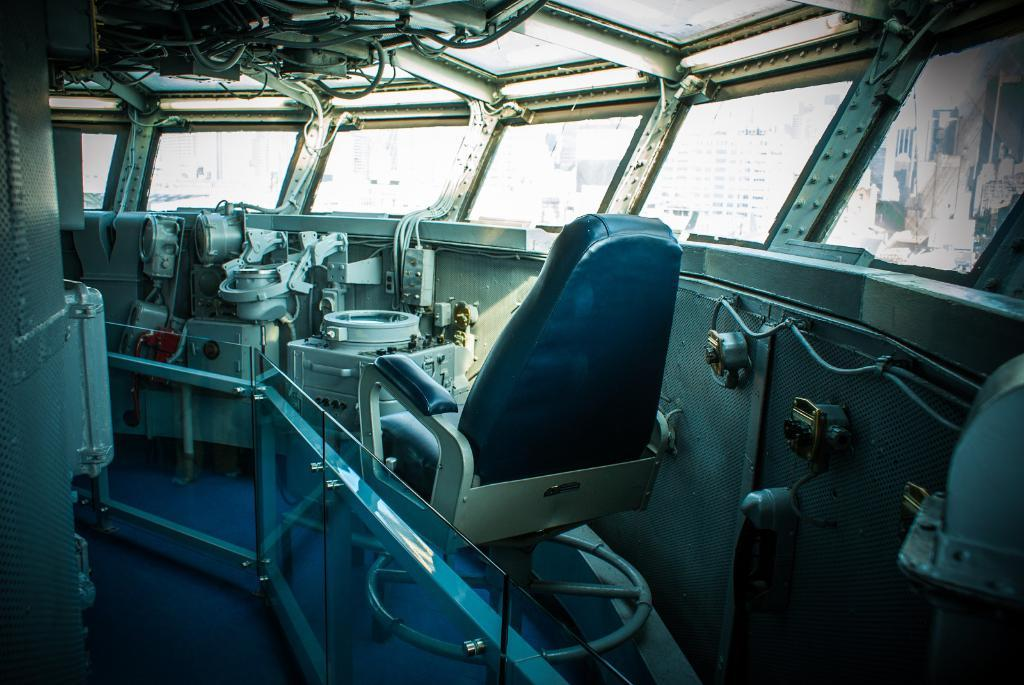What type of equipment or tools can be seen in the image? There is machinery in the image. What type of furniture is present in the image? There is a chair in the image. What safety feature can be seen in the image? There is a railing in the image. What object is placed on the railing? There is a glass on the railing. What architectural feature is visible in the image? There is a window in the image. What can be seen through the window? Buildings are visible through the window. How many dinosaurs are visible in the image? There are no dinosaurs present in the image. What type of truck can be seen driving through the window? There is no truck visible in the image; only buildings can be seen through the window. 